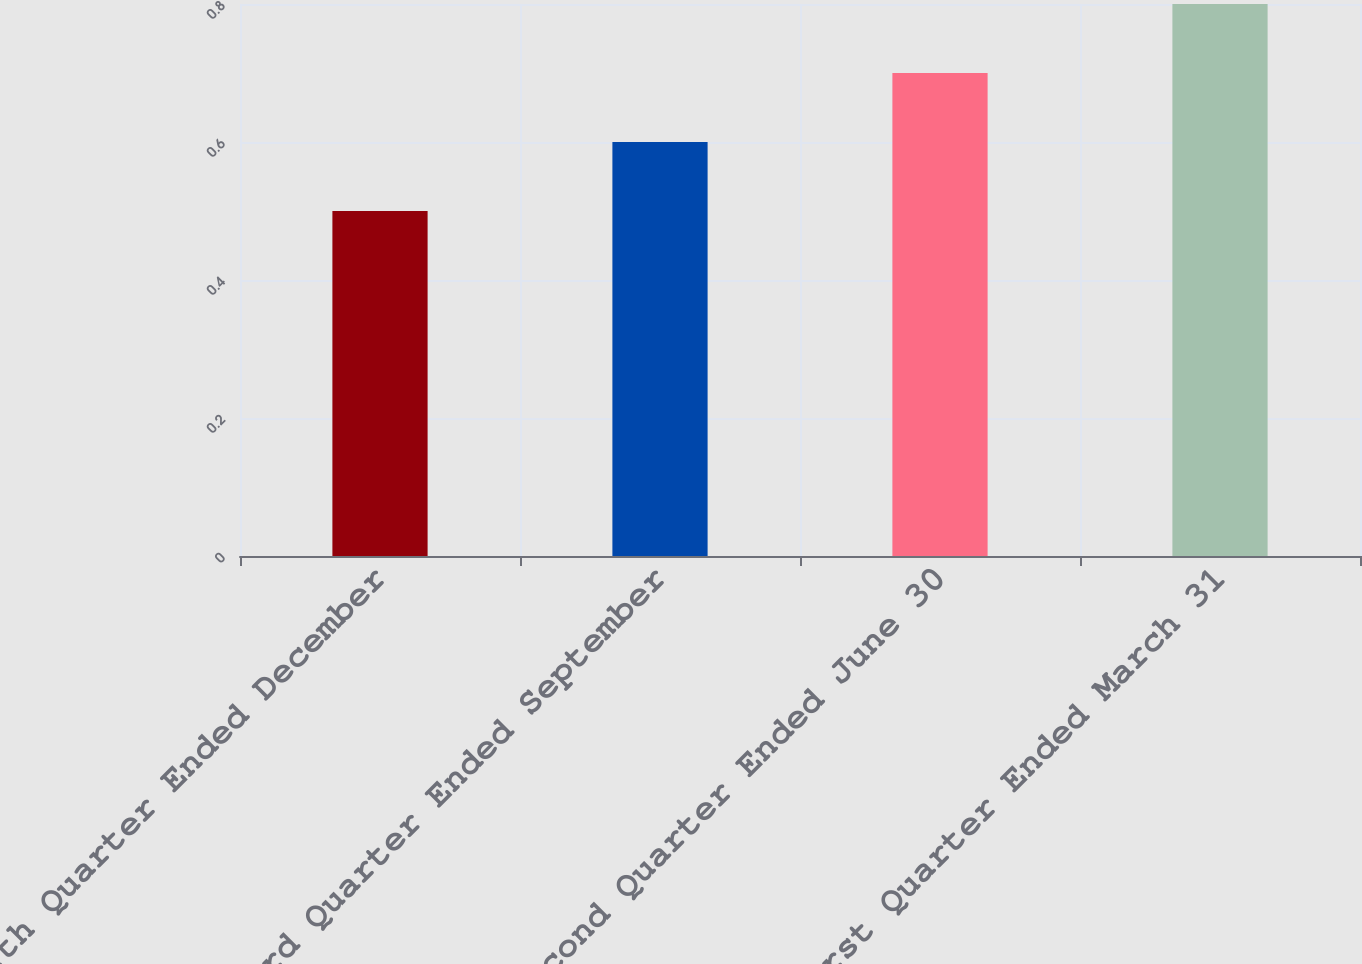Convert chart. <chart><loc_0><loc_0><loc_500><loc_500><bar_chart><fcel>Fourth Quarter Ended December<fcel>Third Quarter Ended September<fcel>Second Quarter Ended June 30<fcel>First Quarter Ended March 31<nl><fcel>0.5<fcel>0.6<fcel>0.7<fcel>0.8<nl></chart> 